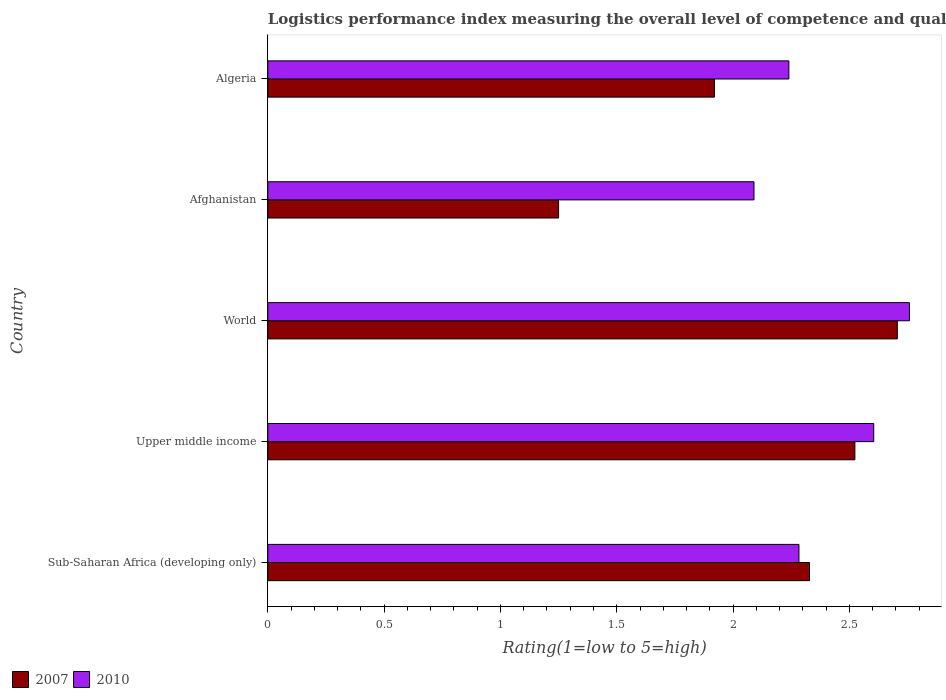How many different coloured bars are there?
Offer a terse response. 2. Are the number of bars per tick equal to the number of legend labels?
Your answer should be compact. Yes. Are the number of bars on each tick of the Y-axis equal?
Provide a succinct answer. Yes. How many bars are there on the 5th tick from the bottom?
Make the answer very short. 2. What is the label of the 5th group of bars from the top?
Your answer should be very brief. Sub-Saharan Africa (developing only). In how many cases, is the number of bars for a given country not equal to the number of legend labels?
Provide a short and direct response. 0. What is the Logistic performance index in 2010 in Sub-Saharan Africa (developing only)?
Keep it short and to the point. 2.28. Across all countries, what is the maximum Logistic performance index in 2007?
Provide a succinct answer. 2.71. Across all countries, what is the minimum Logistic performance index in 2007?
Offer a terse response. 1.25. In which country was the Logistic performance index in 2010 maximum?
Provide a succinct answer. World. In which country was the Logistic performance index in 2010 minimum?
Keep it short and to the point. Afghanistan. What is the total Logistic performance index in 2010 in the graph?
Ensure brevity in your answer.  11.98. What is the difference between the Logistic performance index in 2007 in Afghanistan and that in Sub-Saharan Africa (developing only)?
Your answer should be compact. -1.08. What is the difference between the Logistic performance index in 2007 in Algeria and the Logistic performance index in 2010 in Sub-Saharan Africa (developing only)?
Keep it short and to the point. -0.36. What is the average Logistic performance index in 2010 per country?
Ensure brevity in your answer.  2.4. What is the difference between the Logistic performance index in 2010 and Logistic performance index in 2007 in Sub-Saharan Africa (developing only)?
Provide a succinct answer. -0.05. What is the ratio of the Logistic performance index in 2007 in Algeria to that in Upper middle income?
Give a very brief answer. 0.76. Is the Logistic performance index in 2010 in Algeria less than that in Sub-Saharan Africa (developing only)?
Provide a short and direct response. Yes. What is the difference between the highest and the second highest Logistic performance index in 2007?
Provide a short and direct response. 0.18. What is the difference between the highest and the lowest Logistic performance index in 2007?
Offer a very short reply. 1.46. Is the sum of the Logistic performance index in 2007 in Afghanistan and World greater than the maximum Logistic performance index in 2010 across all countries?
Your answer should be compact. Yes. Are all the bars in the graph horizontal?
Provide a short and direct response. Yes. Does the graph contain any zero values?
Provide a succinct answer. No. How many legend labels are there?
Keep it short and to the point. 2. What is the title of the graph?
Provide a succinct answer. Logistics performance index measuring the overall level of competence and quality of logistics services. What is the label or title of the X-axis?
Your response must be concise. Rating(1=low to 5=high). What is the label or title of the Y-axis?
Your answer should be very brief. Country. What is the Rating(1=low to 5=high) in 2007 in Sub-Saharan Africa (developing only)?
Make the answer very short. 2.33. What is the Rating(1=low to 5=high) in 2010 in Sub-Saharan Africa (developing only)?
Your answer should be compact. 2.28. What is the Rating(1=low to 5=high) in 2007 in Upper middle income?
Provide a short and direct response. 2.52. What is the Rating(1=low to 5=high) of 2010 in Upper middle income?
Give a very brief answer. 2.6. What is the Rating(1=low to 5=high) of 2007 in World?
Give a very brief answer. 2.71. What is the Rating(1=low to 5=high) of 2010 in World?
Keep it short and to the point. 2.76. What is the Rating(1=low to 5=high) in 2010 in Afghanistan?
Your answer should be compact. 2.09. What is the Rating(1=low to 5=high) in 2007 in Algeria?
Give a very brief answer. 1.92. What is the Rating(1=low to 5=high) of 2010 in Algeria?
Your answer should be compact. 2.24. Across all countries, what is the maximum Rating(1=low to 5=high) of 2007?
Keep it short and to the point. 2.71. Across all countries, what is the maximum Rating(1=low to 5=high) in 2010?
Provide a short and direct response. 2.76. Across all countries, what is the minimum Rating(1=low to 5=high) of 2007?
Offer a terse response. 1.25. Across all countries, what is the minimum Rating(1=low to 5=high) in 2010?
Your response must be concise. 2.09. What is the total Rating(1=low to 5=high) in 2007 in the graph?
Make the answer very short. 10.73. What is the total Rating(1=low to 5=high) in 2010 in the graph?
Your response must be concise. 11.98. What is the difference between the Rating(1=low to 5=high) of 2007 in Sub-Saharan Africa (developing only) and that in Upper middle income?
Offer a terse response. -0.2. What is the difference between the Rating(1=low to 5=high) in 2010 in Sub-Saharan Africa (developing only) and that in Upper middle income?
Give a very brief answer. -0.32. What is the difference between the Rating(1=low to 5=high) in 2007 in Sub-Saharan Africa (developing only) and that in World?
Make the answer very short. -0.38. What is the difference between the Rating(1=low to 5=high) in 2010 in Sub-Saharan Africa (developing only) and that in World?
Provide a short and direct response. -0.47. What is the difference between the Rating(1=low to 5=high) of 2007 in Sub-Saharan Africa (developing only) and that in Afghanistan?
Provide a short and direct response. 1.08. What is the difference between the Rating(1=low to 5=high) of 2010 in Sub-Saharan Africa (developing only) and that in Afghanistan?
Ensure brevity in your answer.  0.19. What is the difference between the Rating(1=low to 5=high) of 2007 in Sub-Saharan Africa (developing only) and that in Algeria?
Make the answer very short. 0.41. What is the difference between the Rating(1=low to 5=high) in 2010 in Sub-Saharan Africa (developing only) and that in Algeria?
Provide a succinct answer. 0.04. What is the difference between the Rating(1=low to 5=high) of 2007 in Upper middle income and that in World?
Your answer should be compact. -0.18. What is the difference between the Rating(1=low to 5=high) of 2010 in Upper middle income and that in World?
Make the answer very short. -0.15. What is the difference between the Rating(1=low to 5=high) of 2007 in Upper middle income and that in Afghanistan?
Provide a short and direct response. 1.27. What is the difference between the Rating(1=low to 5=high) of 2010 in Upper middle income and that in Afghanistan?
Make the answer very short. 0.51. What is the difference between the Rating(1=low to 5=high) of 2007 in Upper middle income and that in Algeria?
Make the answer very short. 0.6. What is the difference between the Rating(1=low to 5=high) of 2010 in Upper middle income and that in Algeria?
Make the answer very short. 0.36. What is the difference between the Rating(1=low to 5=high) of 2007 in World and that in Afghanistan?
Your answer should be very brief. 1.46. What is the difference between the Rating(1=low to 5=high) of 2010 in World and that in Afghanistan?
Your answer should be very brief. 0.67. What is the difference between the Rating(1=low to 5=high) in 2007 in World and that in Algeria?
Keep it short and to the point. 0.79. What is the difference between the Rating(1=low to 5=high) in 2010 in World and that in Algeria?
Your answer should be compact. 0.52. What is the difference between the Rating(1=low to 5=high) of 2007 in Afghanistan and that in Algeria?
Give a very brief answer. -0.67. What is the difference between the Rating(1=low to 5=high) of 2007 in Sub-Saharan Africa (developing only) and the Rating(1=low to 5=high) of 2010 in Upper middle income?
Offer a terse response. -0.28. What is the difference between the Rating(1=low to 5=high) of 2007 in Sub-Saharan Africa (developing only) and the Rating(1=low to 5=high) of 2010 in World?
Ensure brevity in your answer.  -0.43. What is the difference between the Rating(1=low to 5=high) of 2007 in Sub-Saharan Africa (developing only) and the Rating(1=low to 5=high) of 2010 in Afghanistan?
Your answer should be compact. 0.24. What is the difference between the Rating(1=low to 5=high) in 2007 in Sub-Saharan Africa (developing only) and the Rating(1=low to 5=high) in 2010 in Algeria?
Give a very brief answer. 0.09. What is the difference between the Rating(1=low to 5=high) of 2007 in Upper middle income and the Rating(1=low to 5=high) of 2010 in World?
Offer a very short reply. -0.23. What is the difference between the Rating(1=low to 5=high) in 2007 in Upper middle income and the Rating(1=low to 5=high) in 2010 in Afghanistan?
Provide a succinct answer. 0.43. What is the difference between the Rating(1=low to 5=high) of 2007 in Upper middle income and the Rating(1=low to 5=high) of 2010 in Algeria?
Give a very brief answer. 0.28. What is the difference between the Rating(1=low to 5=high) of 2007 in World and the Rating(1=low to 5=high) of 2010 in Afghanistan?
Your response must be concise. 0.62. What is the difference between the Rating(1=low to 5=high) in 2007 in World and the Rating(1=low to 5=high) in 2010 in Algeria?
Ensure brevity in your answer.  0.47. What is the difference between the Rating(1=low to 5=high) of 2007 in Afghanistan and the Rating(1=low to 5=high) of 2010 in Algeria?
Provide a short and direct response. -0.99. What is the average Rating(1=low to 5=high) in 2007 per country?
Your answer should be compact. 2.15. What is the average Rating(1=low to 5=high) in 2010 per country?
Ensure brevity in your answer.  2.4. What is the difference between the Rating(1=low to 5=high) in 2007 and Rating(1=low to 5=high) in 2010 in Sub-Saharan Africa (developing only)?
Your answer should be very brief. 0.05. What is the difference between the Rating(1=low to 5=high) of 2007 and Rating(1=low to 5=high) of 2010 in Upper middle income?
Give a very brief answer. -0.08. What is the difference between the Rating(1=low to 5=high) in 2007 and Rating(1=low to 5=high) in 2010 in World?
Offer a very short reply. -0.05. What is the difference between the Rating(1=low to 5=high) in 2007 and Rating(1=low to 5=high) in 2010 in Afghanistan?
Your answer should be compact. -0.84. What is the difference between the Rating(1=low to 5=high) in 2007 and Rating(1=low to 5=high) in 2010 in Algeria?
Your answer should be compact. -0.32. What is the ratio of the Rating(1=low to 5=high) of 2007 in Sub-Saharan Africa (developing only) to that in Upper middle income?
Offer a very short reply. 0.92. What is the ratio of the Rating(1=low to 5=high) in 2010 in Sub-Saharan Africa (developing only) to that in Upper middle income?
Provide a succinct answer. 0.88. What is the ratio of the Rating(1=low to 5=high) in 2007 in Sub-Saharan Africa (developing only) to that in World?
Give a very brief answer. 0.86. What is the ratio of the Rating(1=low to 5=high) in 2010 in Sub-Saharan Africa (developing only) to that in World?
Ensure brevity in your answer.  0.83. What is the ratio of the Rating(1=low to 5=high) of 2007 in Sub-Saharan Africa (developing only) to that in Afghanistan?
Ensure brevity in your answer.  1.86. What is the ratio of the Rating(1=low to 5=high) in 2010 in Sub-Saharan Africa (developing only) to that in Afghanistan?
Your answer should be very brief. 1.09. What is the ratio of the Rating(1=low to 5=high) of 2007 in Sub-Saharan Africa (developing only) to that in Algeria?
Offer a terse response. 1.21. What is the ratio of the Rating(1=low to 5=high) in 2010 in Sub-Saharan Africa (developing only) to that in Algeria?
Your response must be concise. 1.02. What is the ratio of the Rating(1=low to 5=high) in 2007 in Upper middle income to that in World?
Provide a short and direct response. 0.93. What is the ratio of the Rating(1=low to 5=high) of 2010 in Upper middle income to that in World?
Make the answer very short. 0.94. What is the ratio of the Rating(1=low to 5=high) in 2007 in Upper middle income to that in Afghanistan?
Provide a succinct answer. 2.02. What is the ratio of the Rating(1=low to 5=high) in 2010 in Upper middle income to that in Afghanistan?
Provide a short and direct response. 1.25. What is the ratio of the Rating(1=low to 5=high) in 2007 in Upper middle income to that in Algeria?
Offer a terse response. 1.31. What is the ratio of the Rating(1=low to 5=high) of 2010 in Upper middle income to that in Algeria?
Keep it short and to the point. 1.16. What is the ratio of the Rating(1=low to 5=high) in 2007 in World to that in Afghanistan?
Ensure brevity in your answer.  2.17. What is the ratio of the Rating(1=low to 5=high) of 2010 in World to that in Afghanistan?
Offer a terse response. 1.32. What is the ratio of the Rating(1=low to 5=high) in 2007 in World to that in Algeria?
Keep it short and to the point. 1.41. What is the ratio of the Rating(1=low to 5=high) of 2010 in World to that in Algeria?
Make the answer very short. 1.23. What is the ratio of the Rating(1=low to 5=high) in 2007 in Afghanistan to that in Algeria?
Provide a succinct answer. 0.65. What is the ratio of the Rating(1=low to 5=high) in 2010 in Afghanistan to that in Algeria?
Offer a terse response. 0.93. What is the difference between the highest and the second highest Rating(1=low to 5=high) in 2007?
Ensure brevity in your answer.  0.18. What is the difference between the highest and the second highest Rating(1=low to 5=high) in 2010?
Give a very brief answer. 0.15. What is the difference between the highest and the lowest Rating(1=low to 5=high) in 2007?
Make the answer very short. 1.46. What is the difference between the highest and the lowest Rating(1=low to 5=high) in 2010?
Your answer should be very brief. 0.67. 